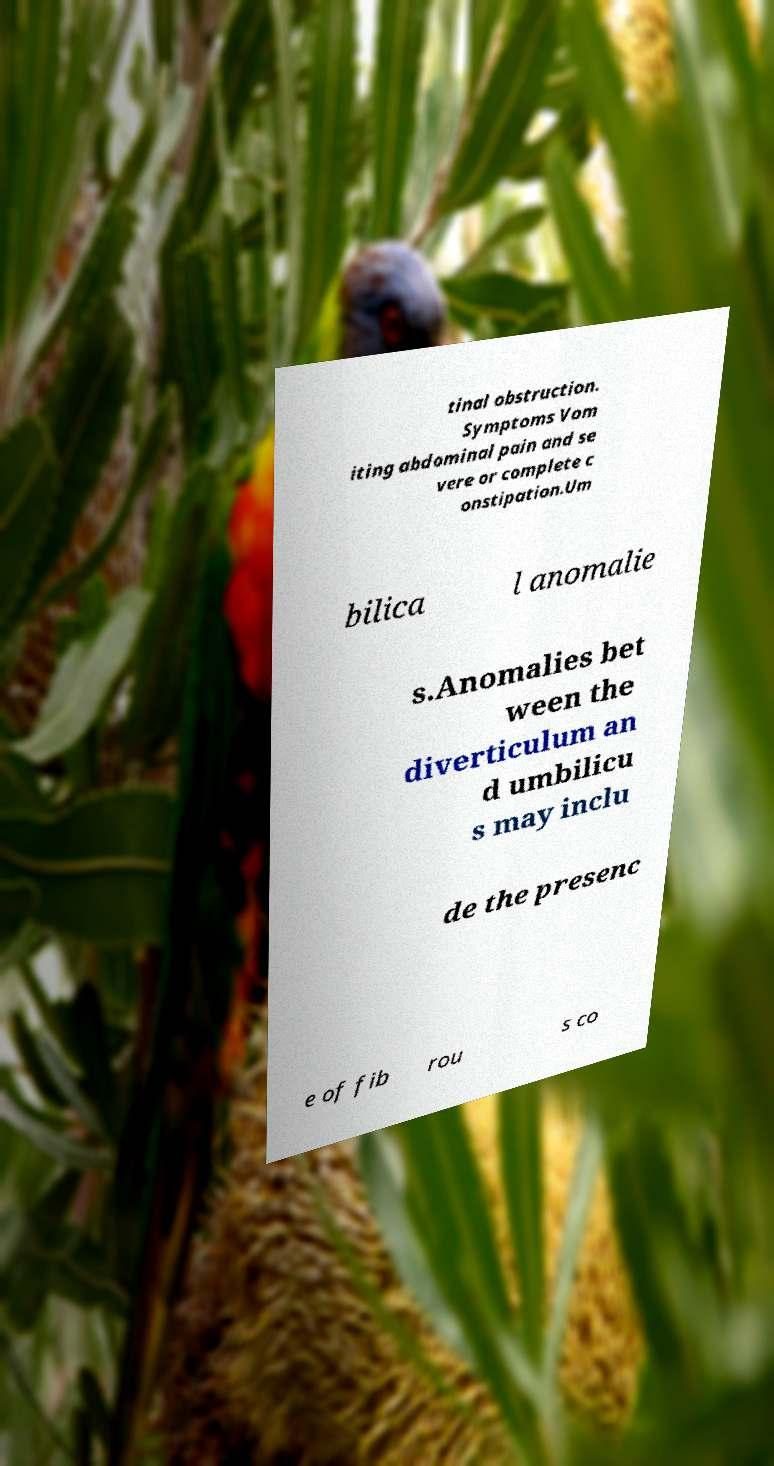Could you assist in decoding the text presented in this image and type it out clearly? tinal obstruction. Symptoms Vom iting abdominal pain and se vere or complete c onstipation.Um bilica l anomalie s.Anomalies bet ween the diverticulum an d umbilicu s may inclu de the presenc e of fib rou s co 